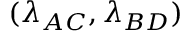Convert formula to latex. <formula><loc_0><loc_0><loc_500><loc_500>( \lambda _ { A C } , \lambda _ { B D } )</formula> 